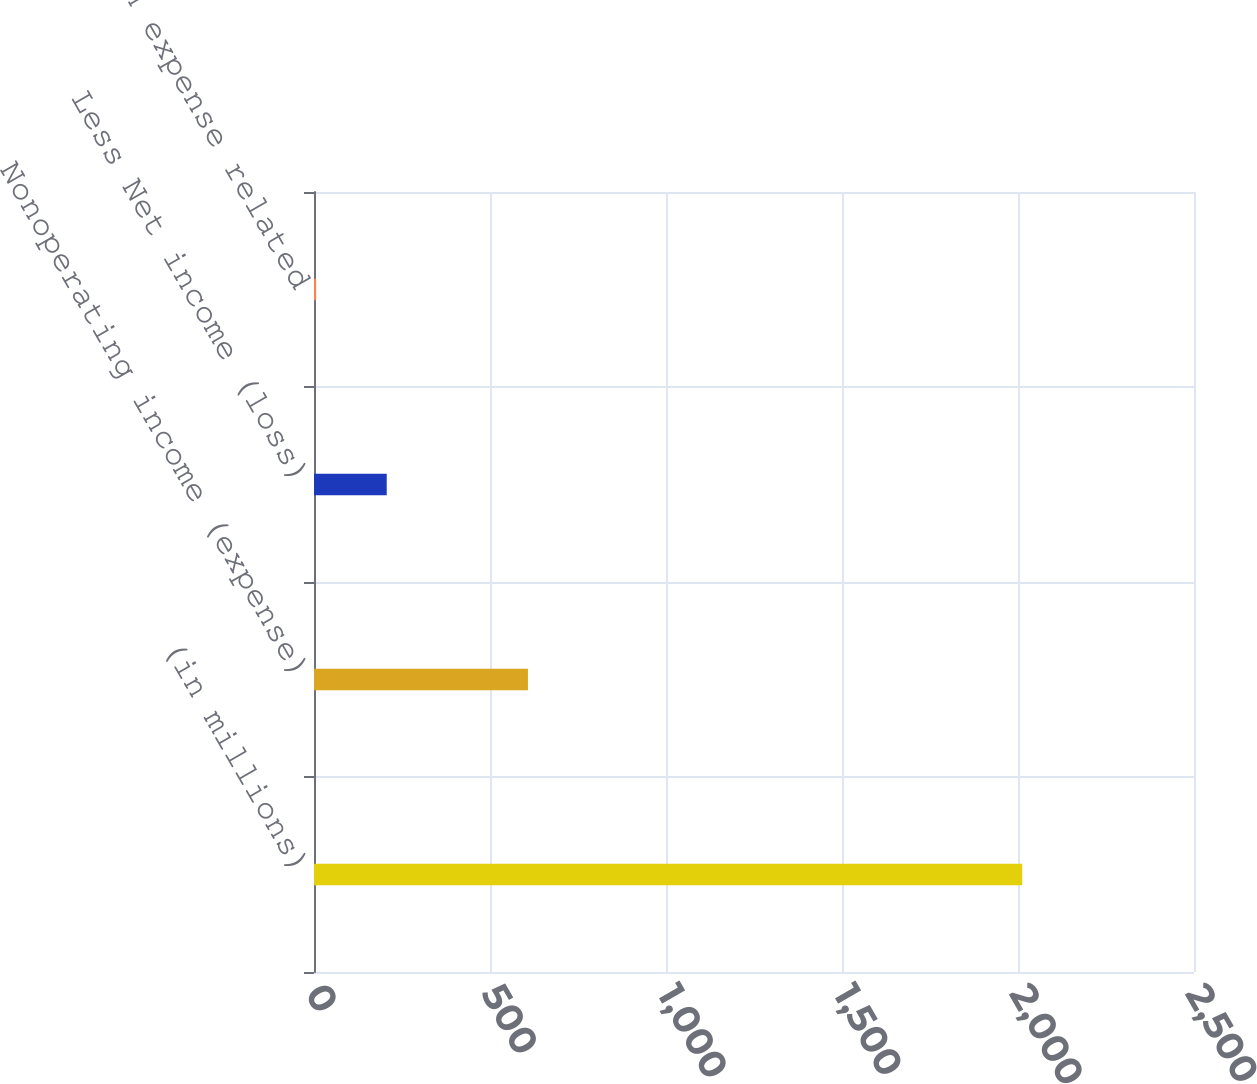Convert chart to OTSL. <chart><loc_0><loc_0><loc_500><loc_500><bar_chart><fcel>(in millions)<fcel>Nonoperating income (expense)<fcel>Less Net income (loss)<fcel>Compensation expense related<nl><fcel>2012<fcel>607.8<fcel>206.6<fcel>6<nl></chart> 